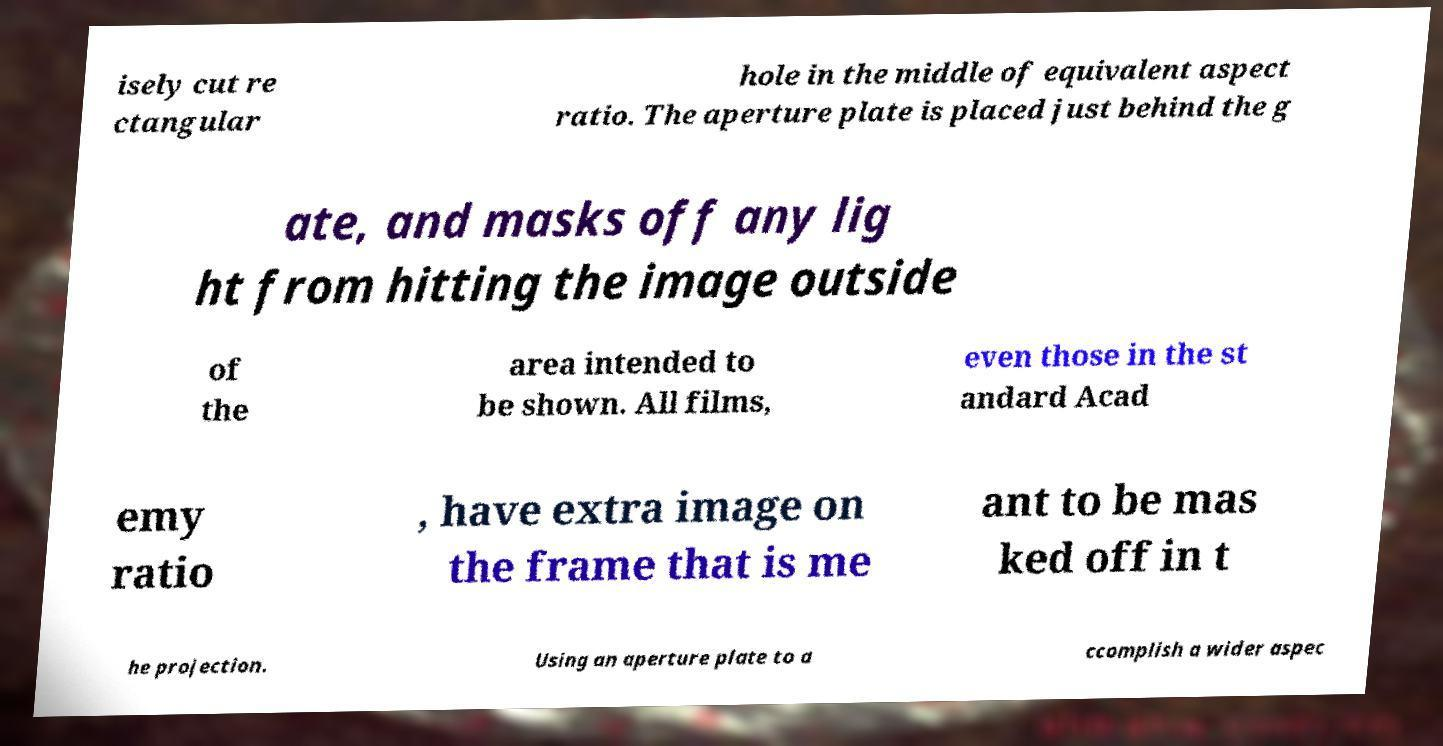There's text embedded in this image that I need extracted. Can you transcribe it verbatim? isely cut re ctangular hole in the middle of equivalent aspect ratio. The aperture plate is placed just behind the g ate, and masks off any lig ht from hitting the image outside of the area intended to be shown. All films, even those in the st andard Acad emy ratio , have extra image on the frame that is me ant to be mas ked off in t he projection. Using an aperture plate to a ccomplish a wider aspec 